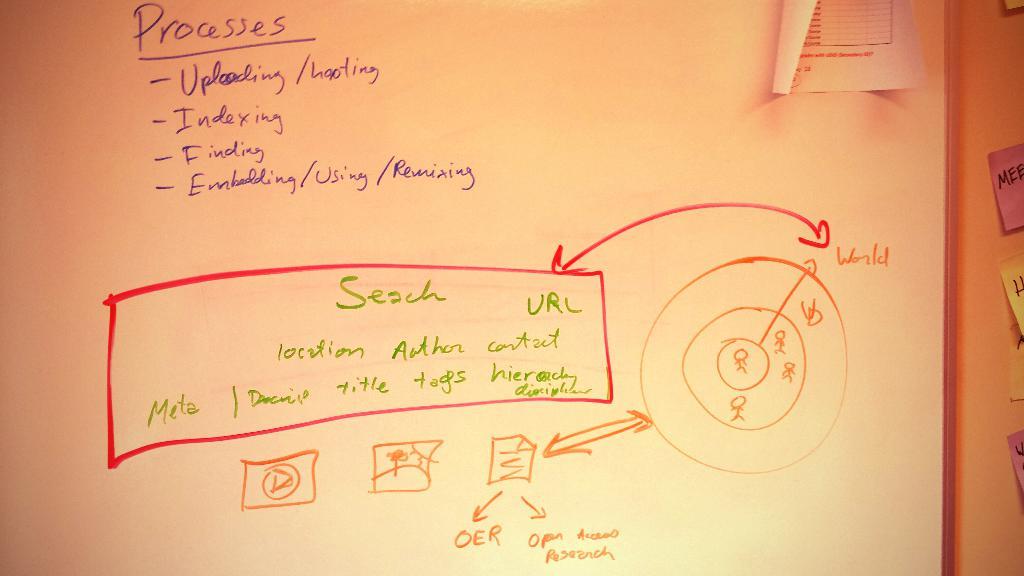What is the first process?
Provide a succinct answer. Uploading. What is the second process?
Provide a short and direct response. Indexing. 